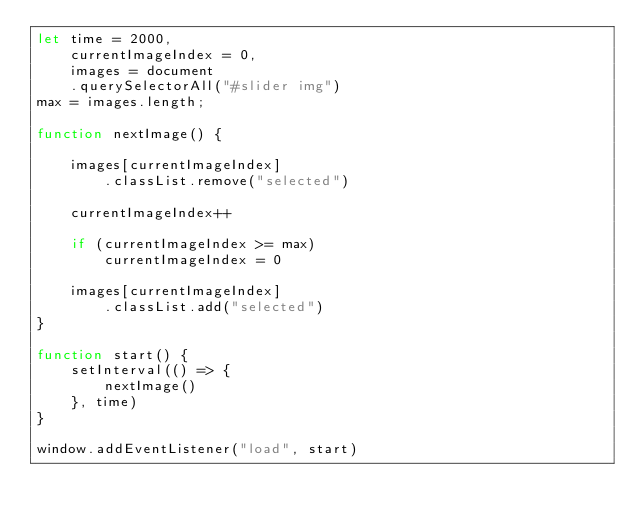<code> <loc_0><loc_0><loc_500><loc_500><_JavaScript_>let time = 2000,
    currentImageIndex = 0,
    images = document
    .querySelectorAll("#slider img")
max = images.length;

function nextImage() {

    images[currentImageIndex]
        .classList.remove("selected")

    currentImageIndex++

    if (currentImageIndex >= max)
        currentImageIndex = 0

    images[currentImageIndex]
        .classList.add("selected")
}

function start() {
    setInterval(() => {
        nextImage()
    }, time)
}

window.addEventListener("load", start)</code> 